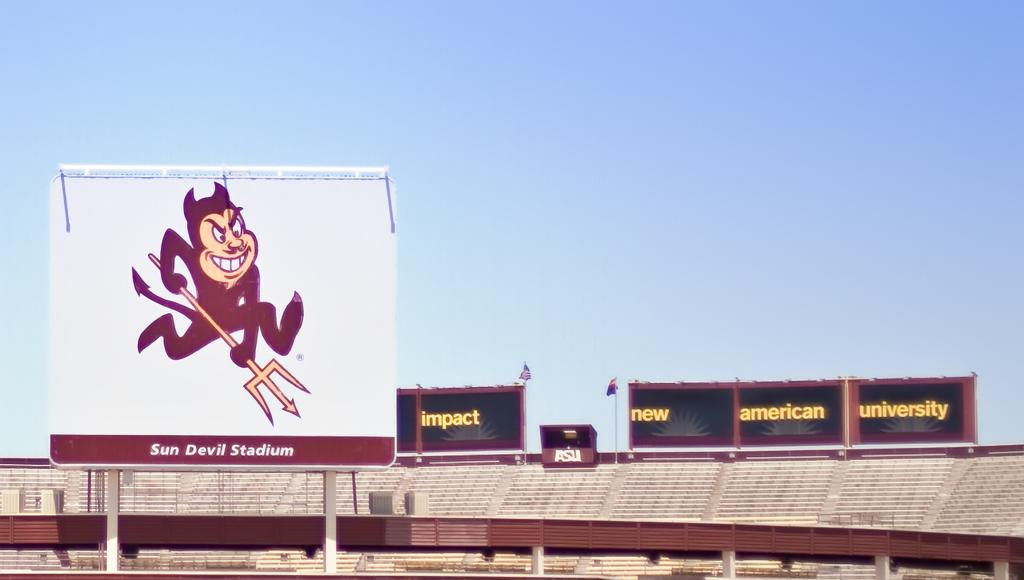<image>
Relay a brief, clear account of the picture shown. The red devil smiles at the Sun Devil Stadium. 